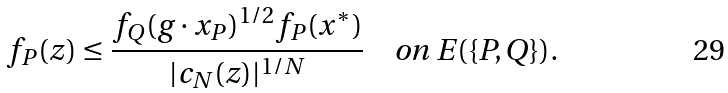<formula> <loc_0><loc_0><loc_500><loc_500>f _ { P } ( z ) \leq \frac { f _ { Q } ( g \cdot x _ { P } ) ^ { 1 / 2 } f _ { P } ( x ^ { * } ) } { | c _ { N } ( z ) | ^ { 1 / N } } \quad \text {on $E(\{P,Q\})$.}</formula> 